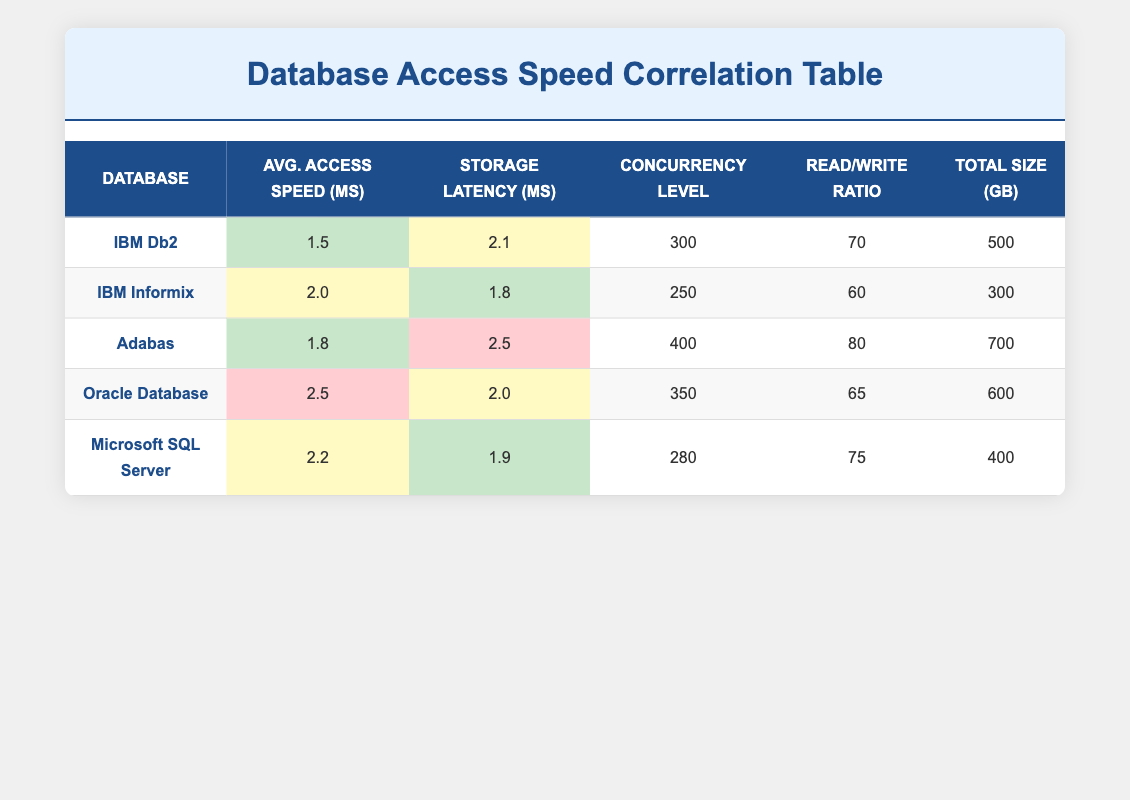What is the average access speed of IBM Db2? The table shows the average access speed for IBM Db2 as 1.5 ms, which is listed in the corresponding row under the "Avg. Access Speed (ms)" column.
Answer: 1.5 ms Which database has the highest storage latency? By comparing the "Storage Latency (ms)" values, Adabas has the highest latency at 2.5 ms. This value is greater than all others listed.
Answer: Adabas What is the difference in average access speed between Oracle Database and IBM Db2? The average access speed for Oracle Database is 2.5 ms, while for IBM Db2 it is 1.5 ms. The difference is 2.5 - 1.5 = 1.0 ms.
Answer: 1.0 ms Is the read/write ratio for IBM Informix higher than that of Microsoft SQL Server? The read/write ratio for IBM Informix is 60, while for Microsoft SQL Server it is 75. Since 60 is less than 75, the statement is false.
Answer: No Calculate the average storage latency of all databases. The storage latencies are: IBM Db2 (2.1 ms), IBM Informix (1.8 ms), Adabas (2.5 ms), Oracle Database (2.0 ms), and Microsoft SQL Server (1.9 ms). The sum is 2.1 + 1.8 + 2.5 + 2.0 + 1.9 = 10.3 ms. There are 5 databases, so the average is 10.3 / 5 = 2.06 ms.
Answer: 2.06 ms Which database has the highest concurrency level? By looking at the "Concurrency Level" column, Adabas has the highest value at 400.
Answer: Adabas Is it true that the total size of Oracle Database is larger than that of IBM Informix? The total size of Oracle Database is 600 GB and for IBM Informix it is 300 GB. Since 600 is greater than 300, the statement is true.
Answer: Yes What is the combined read/write ratio of all databases? The read/write ratios are: IBM Db2 (70), IBM Informix (60), Adabas (80), Oracle Database (65), Microsoft SQL Server (75). The sum is 70 + 60 + 80 + 65 + 75 = 350.
Answer: 350 What is the average total size of all databases listed? The total sizes are: IBM Db2 (500 GB), IBM Informix (300 GB), Adabas (700 GB), Oracle Database (600 GB), Microsoft SQL Server (400 GB). The sum is 500 + 300 + 700 + 600 + 400 = 2500 GB. There are 5 databases, so the average is 2500 / 5 = 500 GB.
Answer: 500 GB 